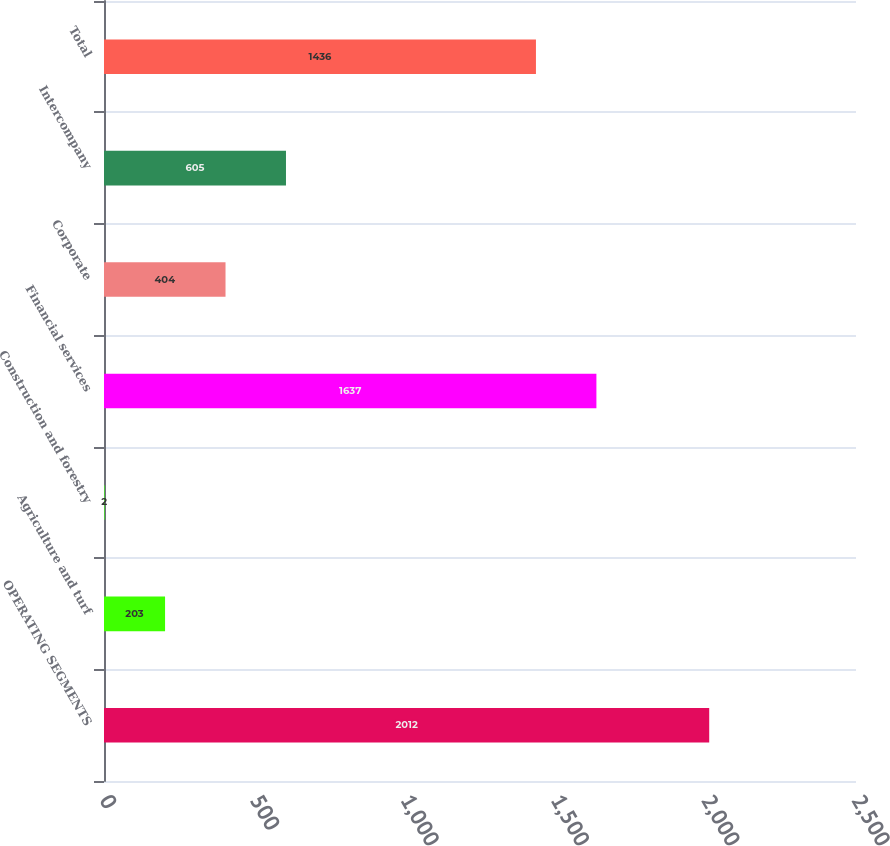Convert chart. <chart><loc_0><loc_0><loc_500><loc_500><bar_chart><fcel>OPERATING SEGMENTS<fcel>Agriculture and turf<fcel>Construction and forestry<fcel>Financial services<fcel>Corporate<fcel>Intercompany<fcel>Total<nl><fcel>2012<fcel>203<fcel>2<fcel>1637<fcel>404<fcel>605<fcel>1436<nl></chart> 